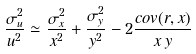<formula> <loc_0><loc_0><loc_500><loc_500>\frac { \sigma _ { u } ^ { 2 } } { u ^ { 2 } } \simeq \frac { \sigma _ { x } ^ { 2 } } { x ^ { 2 } } + \frac { \sigma _ { y } ^ { 2 } } { y ^ { 2 } } - 2 \frac { { c o v } ( r , x ) } { x \, y }</formula> 